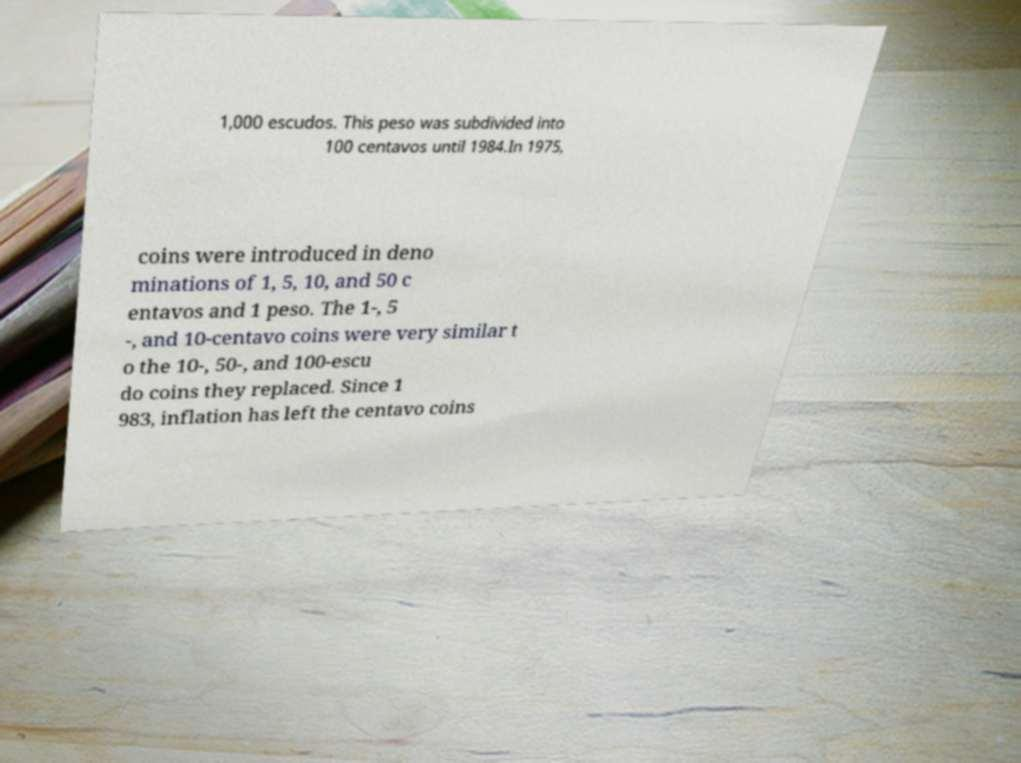For documentation purposes, I need the text within this image transcribed. Could you provide that? 1,000 escudos. This peso was subdivided into 100 centavos until 1984.In 1975, coins were introduced in deno minations of 1, 5, 10, and 50 c entavos and 1 peso. The 1-, 5 -, and 10-centavo coins were very similar t o the 10-, 50-, and 100-escu do coins they replaced. Since 1 983, inflation has left the centavo coins 